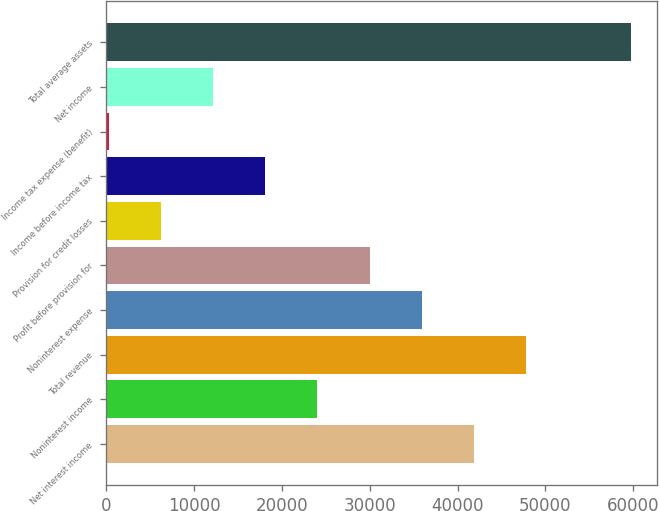Convert chart. <chart><loc_0><loc_0><loc_500><loc_500><bar_chart><fcel>Net interest income<fcel>Noninterest income<fcel>Total revenue<fcel>Noninterest expense<fcel>Profit before provision for<fcel>Provision for credit losses<fcel>Income before income tax<fcel>Income tax expense (benefit)<fcel>Net income<fcel>Total average assets<nl><fcel>41873.6<fcel>24033.2<fcel>47820.4<fcel>35926.8<fcel>29980<fcel>6192.8<fcel>18086.4<fcel>246<fcel>12139.6<fcel>59714<nl></chart> 